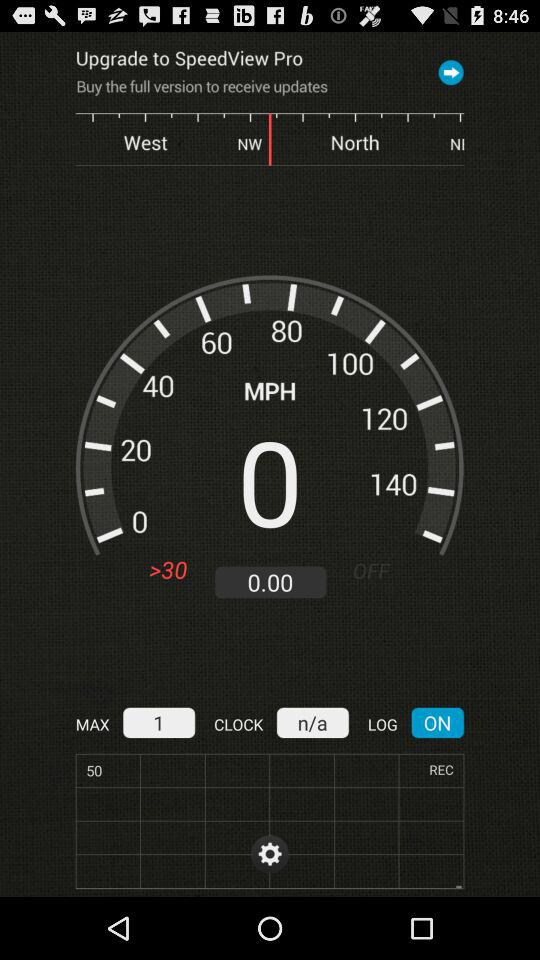What is the difference between the speed of 100 and 60?
Answer the question using a single word or phrase. 40 